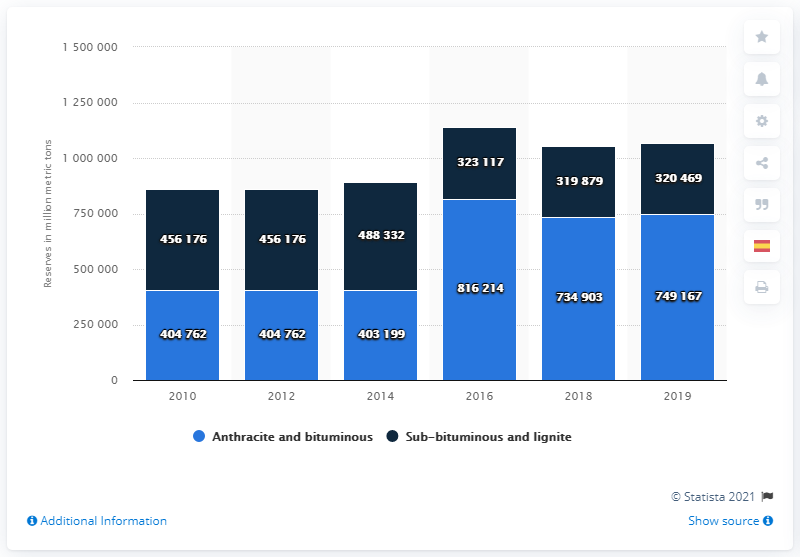Point out several critical features in this image. In 2019, the global proven reserves of anthracite and bituminous coal were estimated to be 749167... 